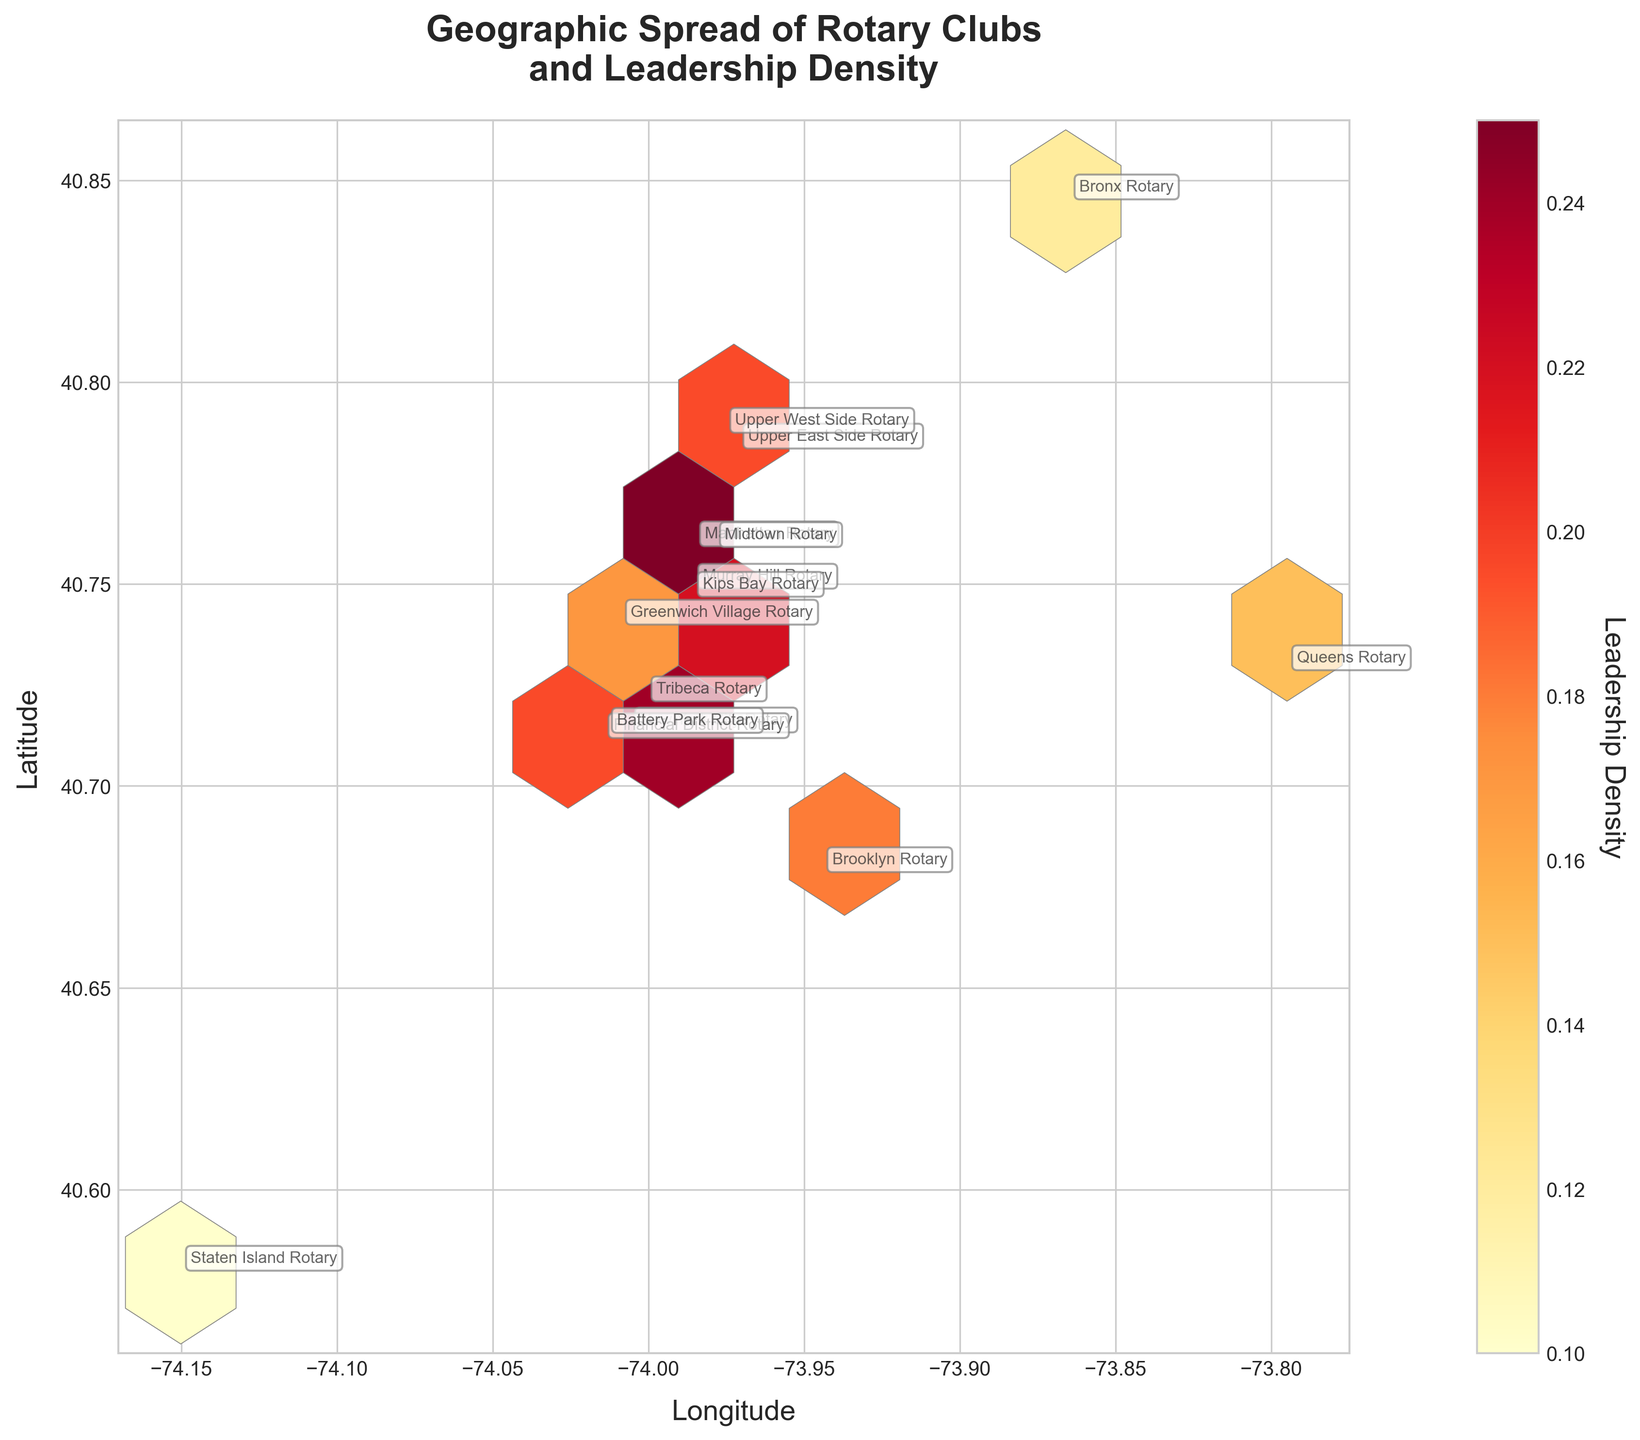What is the title of the hexbin plot? The title is usually located at the top of the figure and represents the main subject or insight of the plot. In this case, the title is clearly shown above the plotted area.
Answer: Geographic Spread of Rotary Clubs and Leadership Density What are the labels of the x and y axes? The labels of the axes are typically located near the ends of the x and y axes. They define what each axis represents in the plot. In this case, the x-axis label is 'Longitude' and the y-axis label is 'Latitude'.
Answer: Longitude and Latitude Which Rotary club has the highest leadership density and what is the density value? By observing either the position of hexagons or reading annotations, we can identify the Rotary club with the highest leadership density. The New York City Rotary, with coordinates (40.7128, -74.0060), has the highest density of 0.32.
Answer: New York City Rotary, 0.32 How does the leadership density color gradient relate to densities? The color gradient in the hexagon bins is crucial for understanding densities. Lighter colors like yellow correspond to higher leadership densities, while darker colors like red correspond to lower densities. This relationship can be observed in the color bar on the side.
Answer: Lighter colors indicate higher densities Which two clubs are geographically the closest? To identify the closest geographically spaced clubs, observe the coordinates and spatial distance between hexagons on the plot. Manhattan Rotary (40.7589, -73.9851) and Midtown Rotary (40.7587, -73.9787) are closest geographically based on their positions.
Answer: Manhattan Rotary and Midtown Rotary How many Rotary clubs are located in Manhattan? Identifying the number of clubs in a specific area like Manhattan requires checking the club names and their respective locations. There are five clubs: Manhattan, Financial District, Midtown, Murray Hill, and Kips Bay.
Answer: 5 Which club in Brooklyn has the lowest leadership density, and what is the density value? By looking at the Brooklyn area coordinates (40.6782, -73.9442), observe the leadership density value provided. Brooklyn Rotary has a density value of 0.18, the lowest among the provided clubs.
Answer: Brooklyn Rotary, 0.18 What is the leadership density range among all Rotary clubs? To find the range, identify the highest and lowest leadership density values from the provided data. The highest leadership density is 0.32 (New York City Rotary) and the lowest is 0.10 (Staten Island Rotary). Subtracting these two values gives the range: 0.32 - 0.10 = 0.22.
Answer: 0.22 Which club has a higher leadership density, Kips Bay Rotary or Greenwich Village Rotary, and by how much? Compare the leadership density values: Kips Bay Rotary has density 0.21 and Greenwich Village Rotary has density 0.17. The difference is 0.21 - 0.17 = 0.04.
Answer: Kips Bay Rotary, 0.04 